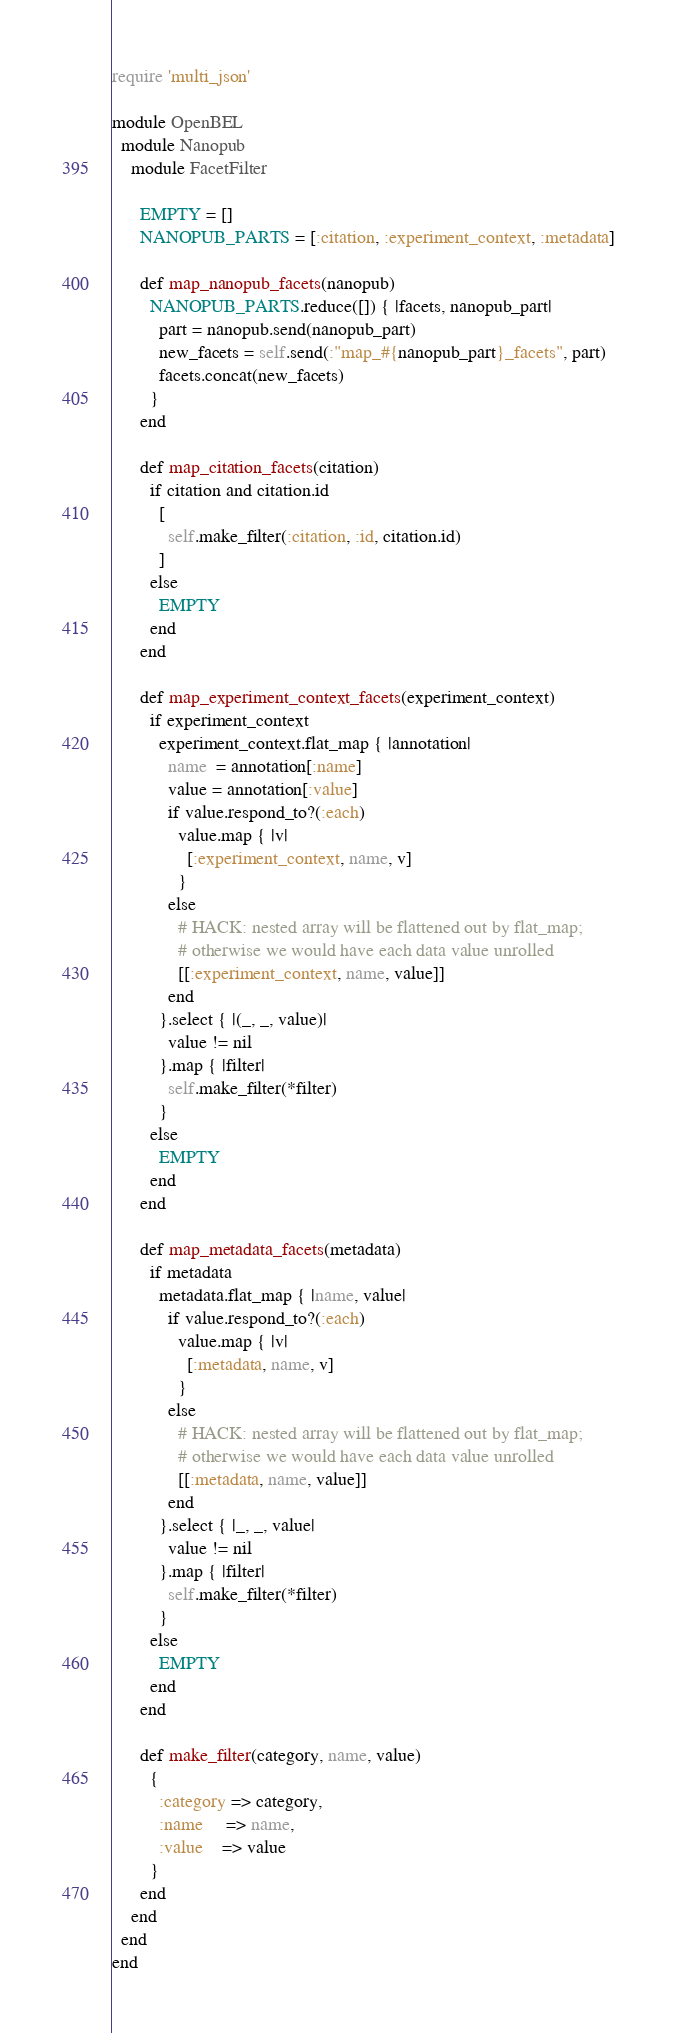<code> <loc_0><loc_0><loc_500><loc_500><_Ruby_>require 'multi_json'

module OpenBEL
  module Nanopub
    module FacetFilter

      EMPTY = []
      NANOPUB_PARTS = [:citation, :experiment_context, :metadata]

      def map_nanopub_facets(nanopub)
        NANOPUB_PARTS.reduce([]) { |facets, nanopub_part|
          part = nanopub.send(nanopub_part)
          new_facets = self.send(:"map_#{nanopub_part}_facets", part)
          facets.concat(new_facets)
        }
      end

      def map_citation_facets(citation)
        if citation and citation.id
          [
            self.make_filter(:citation, :id, citation.id)
          ]
        else
          EMPTY
        end
      end

      def map_experiment_context_facets(experiment_context)
        if experiment_context
          experiment_context.flat_map { |annotation|
            name  = annotation[:name]
            value = annotation[:value]
            if value.respond_to?(:each)
              value.map { |v|
                [:experiment_context, name, v]
              }
            else
              # HACK: nested array will be flattened out by flat_map;
              # otherwise we would have each data value unrolled
              [[:experiment_context, name, value]]
            end
          }.select { |(_, _, value)|
            value != nil
          }.map { |filter|
            self.make_filter(*filter)
          }
        else
          EMPTY
        end
      end

      def map_metadata_facets(metadata)
        if metadata
          metadata.flat_map { |name, value|
            if value.respond_to?(:each)
              value.map { |v|
                [:metadata, name, v]
              }
            else
              # HACK: nested array will be flattened out by flat_map;
              # otherwise we would have each data value unrolled
              [[:metadata, name, value]]
            end
          }.select { |_, _, value|
            value != nil
          }.map { |filter|
            self.make_filter(*filter)
          }
        else
          EMPTY
        end
      end

      def make_filter(category, name, value)
        {
          :category => category,
          :name     => name,
          :value    => value
        }
      end
    end
  end
end
</code> 